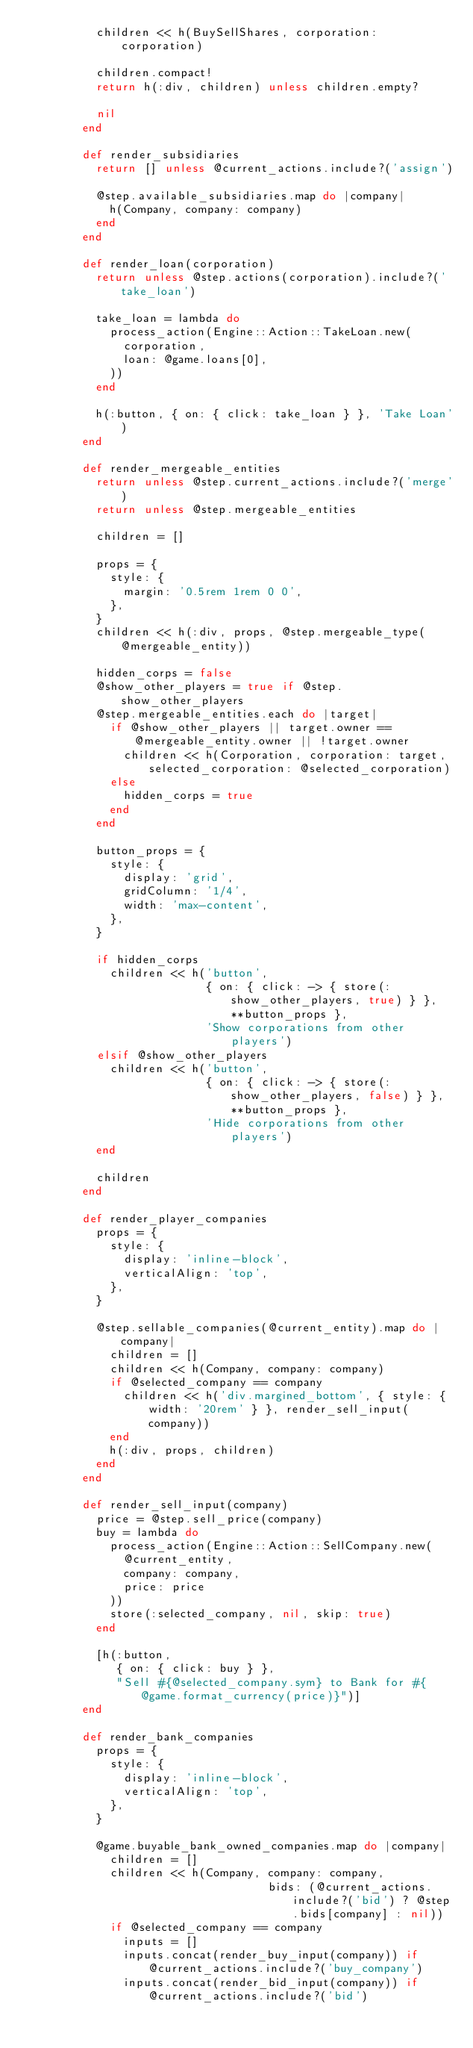Convert code to text. <code><loc_0><loc_0><loc_500><loc_500><_Ruby_>          children << h(BuySellShares, corporation: corporation)

          children.compact!
          return h(:div, children) unless children.empty?

          nil
        end

        def render_subsidiaries
          return [] unless @current_actions.include?('assign')

          @step.available_subsidiaries.map do |company|
            h(Company, company: company)
          end
        end

        def render_loan(corporation)
          return unless @step.actions(corporation).include?('take_loan')

          take_loan = lambda do
            process_action(Engine::Action::TakeLoan.new(
              corporation,
              loan: @game.loans[0],
            ))
          end

          h(:button, { on: { click: take_loan } }, 'Take Loan')
        end

        def render_mergeable_entities
          return unless @step.current_actions.include?('merge')
          return unless @step.mergeable_entities

          children = []

          props = {
            style: {
              margin: '0.5rem 1rem 0 0',
            },
          }
          children << h(:div, props, @step.mergeable_type(@mergeable_entity))

          hidden_corps = false
          @show_other_players = true if @step.show_other_players
          @step.mergeable_entities.each do |target|
            if @show_other_players || target.owner == @mergeable_entity.owner || !target.owner
              children << h(Corporation, corporation: target, selected_corporation: @selected_corporation)
            else
              hidden_corps = true
            end
          end

          button_props = {
            style: {
              display: 'grid',
              gridColumn: '1/4',
              width: 'max-content',
            },
          }

          if hidden_corps
            children << h('button',
                          { on: { click: -> { store(:show_other_players, true) } }, **button_props },
                          'Show corporations from other players')
          elsif @show_other_players
            children << h('button',
                          { on: { click: -> { store(:show_other_players, false) } }, **button_props },
                          'Hide corporations from other players')
          end

          children
        end

        def render_player_companies
          props = {
            style: {
              display: 'inline-block',
              verticalAlign: 'top',
            },
          }

          @step.sellable_companies(@current_entity).map do |company|
            children = []
            children << h(Company, company: company)
            if @selected_company == company
              children << h('div.margined_bottom', { style: { width: '20rem' } }, render_sell_input(company))
            end
            h(:div, props, children)
          end
        end

        def render_sell_input(company)
          price = @step.sell_price(company)
          buy = lambda do
            process_action(Engine::Action::SellCompany.new(
              @current_entity,
              company: company,
              price: price
            ))
            store(:selected_company, nil, skip: true)
          end

          [h(:button,
             { on: { click: buy } },
             "Sell #{@selected_company.sym} to Bank for #{@game.format_currency(price)}")]
        end

        def render_bank_companies
          props = {
            style: {
              display: 'inline-block',
              verticalAlign: 'top',
            },
          }

          @game.buyable_bank_owned_companies.map do |company|
            children = []
            children << h(Company, company: company,
                                   bids: (@current_actions.include?('bid') ? @step.bids[company] : nil))
            if @selected_company == company
              inputs = []
              inputs.concat(render_buy_input(company)) if @current_actions.include?('buy_company')
              inputs.concat(render_bid_input(company)) if @current_actions.include?('bid')</code> 